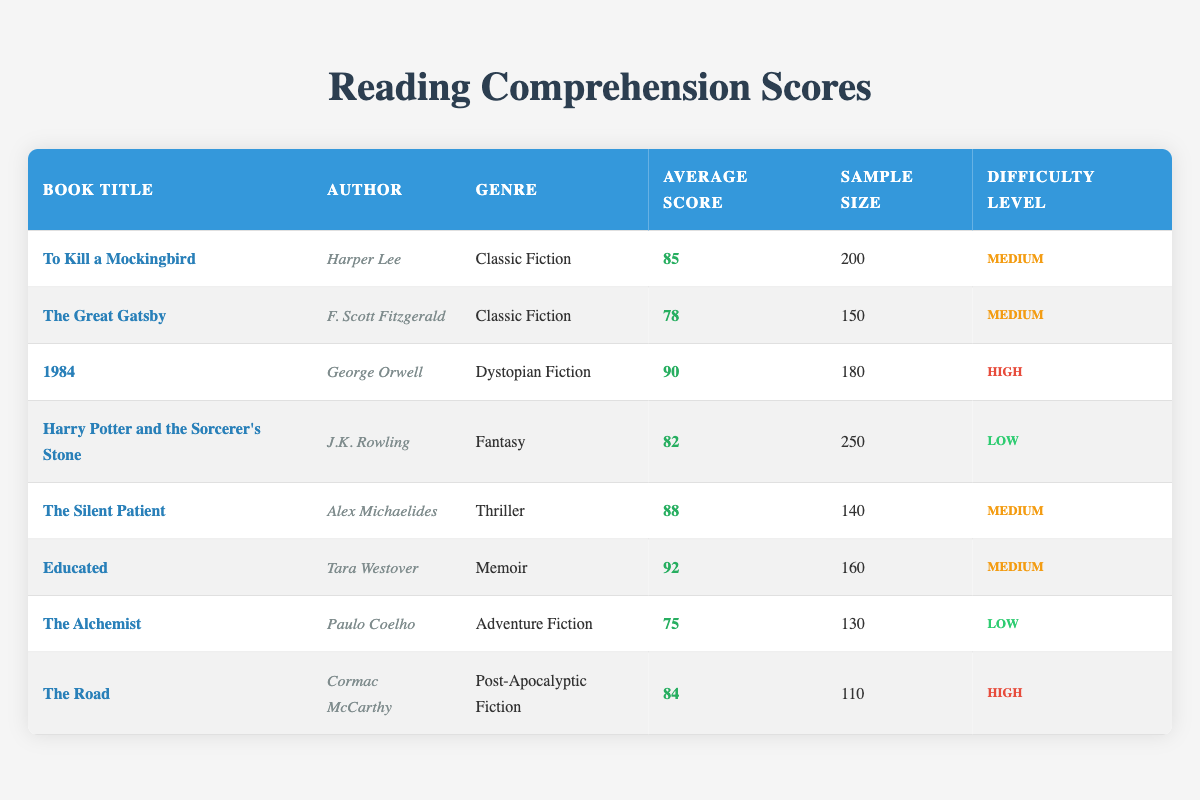What is the average reading comprehension score for Classic Fiction books? There are two Classic Fiction books: "To Kill a Mockingbird" with a score of 85 and "The Great Gatsby" with a score of 78. To find the average, add the scores (85 + 78 = 163) and divide by the number of books (163 / 2 = 81.5).
Answer: 81.5 Which book has the highest average score? By reviewing the average scores from all the books listed, "Educated" has the highest average score of 92.
Answer: Educated True or False: The sample size for "The Great Gatsby" is greater than that for "The Silent Patient." "The Great Gatsby" has a sample size of 150 while "The Silent Patient" has a sample size of 140. Since 150 > 140, the statement is False.
Answer: False What is the average score for books with a 'High' difficulty level? There are two books with 'High' difficulty: "1984" with 90 and "The Road" with 84. To find the average, add the scores (90 + 84 = 174) and divide by the number of books (174 / 2 = 87).
Answer: 87 How many books have an average score of 85 or higher? The books that have an average score of 85 or higher are "To Kill a Mockingbird" (85), "1984" (90), "The Silent Patient" (88), and "Educated" (92). There are four books meeting this criterion.
Answer: 4 What is the average sample size for all books? The sample sizes for the books are 200, 150, 180, 250, 140, 160, 130, and 110. Adding these gives 1320, and dividing by the number of books (8) results in an average sample size of 165.
Answer: 165 Which genre has the lowest average score? The Adventure Fiction book, "The Alchemist," has the lowest average score of 75. Therefore, Adventure Fiction is the genre with the lowest average score.
Answer: Adventure Fiction Are there more books classified as 'Medium' difficulty than 'Low' difficulty? Upon examining the table, there are five books assigned 'Medium' difficulty: "To Kill a Mockingbird," "The Great Gatsby," "The Silent Patient," "Educated," and "Harry Potter and the Sorcerer's Stone" (though it is ‘Low’ difficulty). Since only two books are ‘Low’, there are more books with 'Medium' difficulty.
Answer: Yes 